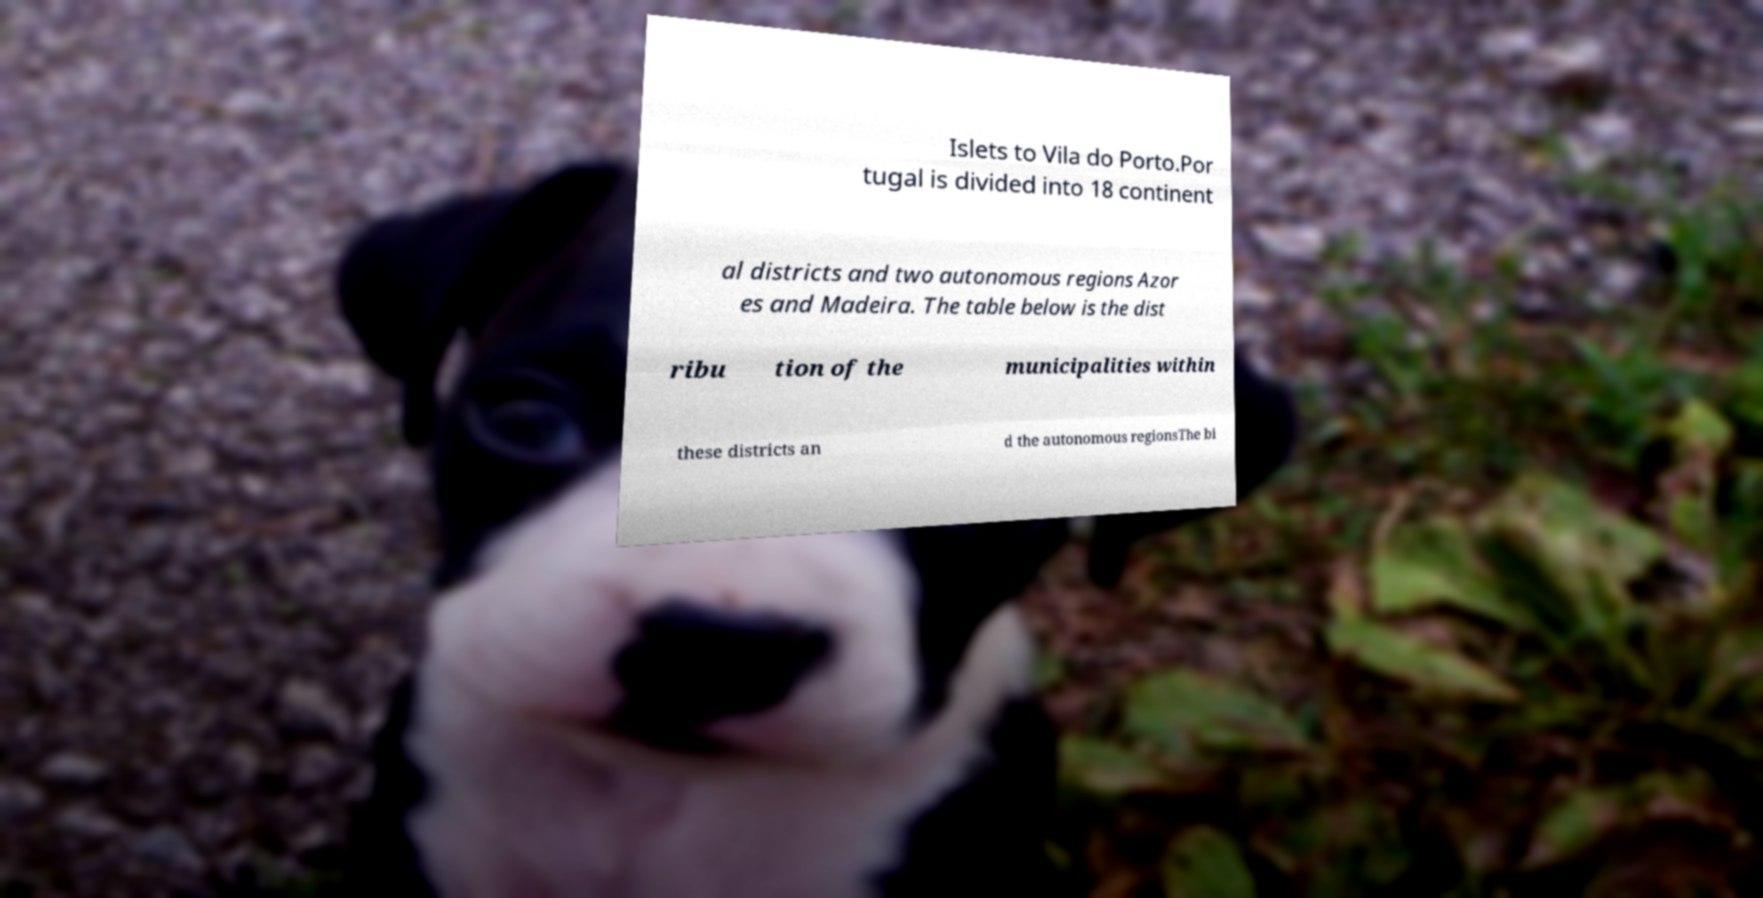What messages or text are displayed in this image? I need them in a readable, typed format. Islets to Vila do Porto.Por tugal is divided into 18 continent al districts and two autonomous regions Azor es and Madeira. The table below is the dist ribu tion of the municipalities within these districts an d the autonomous regionsThe bi 